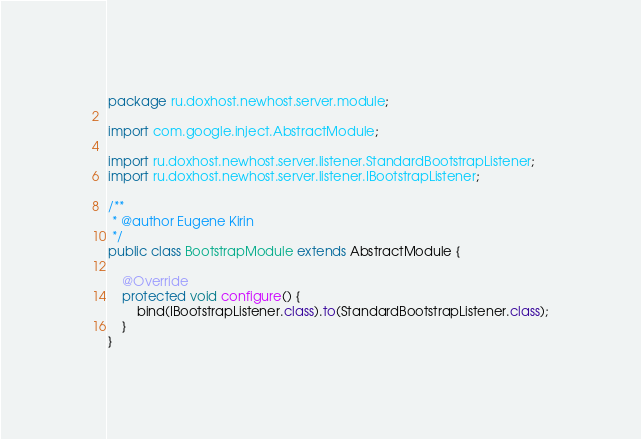<code> <loc_0><loc_0><loc_500><loc_500><_Java_>package ru.doxhost.newhost.server.module;

import com.google.inject.AbstractModule;

import ru.doxhost.newhost.server.listener.StandardBootstrapListener;
import ru.doxhost.newhost.server.listener.IBootstrapListener;

/**
 * @author Eugene Kirin
 */
public class BootstrapModule extends AbstractModule {

    @Override
    protected void configure() {
        bind(IBootstrapListener.class).to(StandardBootstrapListener.class);
    }
}
</code> 